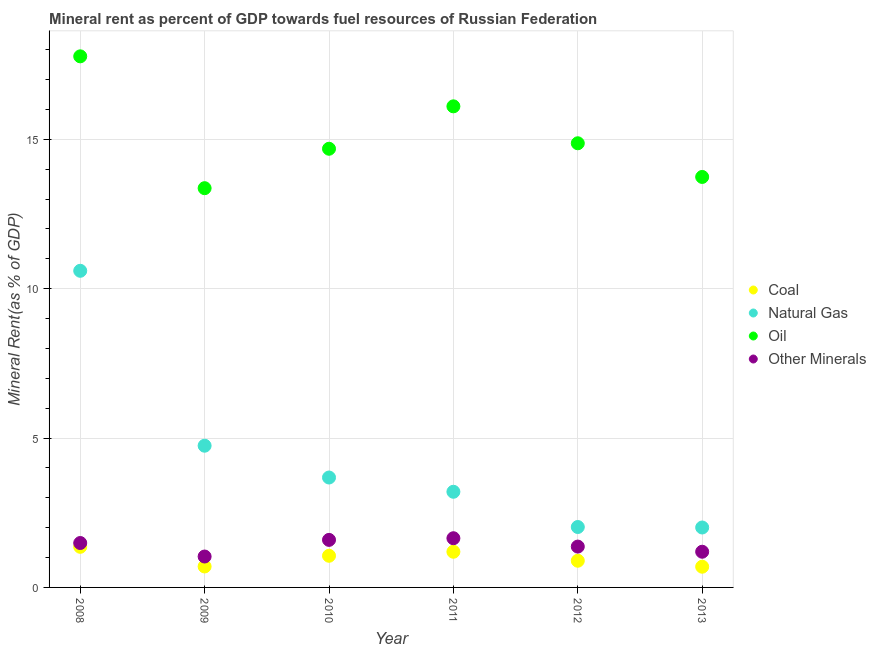How many different coloured dotlines are there?
Your answer should be very brief. 4. Is the number of dotlines equal to the number of legend labels?
Make the answer very short. Yes. What is the  rent of other minerals in 2009?
Offer a terse response. 1.03. Across all years, what is the maximum oil rent?
Give a very brief answer. 17.77. Across all years, what is the minimum oil rent?
Offer a very short reply. 13.36. What is the total natural gas rent in the graph?
Ensure brevity in your answer.  26.25. What is the difference between the natural gas rent in 2009 and that in 2012?
Offer a very short reply. 2.72. What is the difference between the oil rent in 2013 and the  rent of other minerals in 2012?
Your answer should be very brief. 12.37. What is the average coal rent per year?
Keep it short and to the point. 0.98. In the year 2008, what is the difference between the  rent of other minerals and oil rent?
Your answer should be compact. -16.29. What is the ratio of the coal rent in 2012 to that in 2013?
Provide a short and direct response. 1.29. Is the difference between the oil rent in 2009 and 2013 greater than the difference between the coal rent in 2009 and 2013?
Offer a very short reply. No. What is the difference between the highest and the second highest  rent of other minerals?
Offer a terse response. 0.06. What is the difference between the highest and the lowest coal rent?
Offer a terse response. 0.67. Is the sum of the coal rent in 2010 and 2013 greater than the maximum oil rent across all years?
Your response must be concise. No. Is it the case that in every year, the sum of the coal rent and natural gas rent is greater than the oil rent?
Your response must be concise. No. Does the  rent of other minerals monotonically increase over the years?
Your response must be concise. No. How many dotlines are there?
Your answer should be very brief. 4. How many years are there in the graph?
Make the answer very short. 6. What is the difference between two consecutive major ticks on the Y-axis?
Your answer should be very brief. 5. Are the values on the major ticks of Y-axis written in scientific E-notation?
Make the answer very short. No. Does the graph contain grids?
Keep it short and to the point. Yes. Where does the legend appear in the graph?
Provide a short and direct response. Center right. What is the title of the graph?
Provide a succinct answer. Mineral rent as percent of GDP towards fuel resources of Russian Federation. Does "Quality of logistic services" appear as one of the legend labels in the graph?
Offer a terse response. No. What is the label or title of the X-axis?
Provide a short and direct response. Year. What is the label or title of the Y-axis?
Offer a very short reply. Mineral Rent(as % of GDP). What is the Mineral Rent(as % of GDP) in Coal in 2008?
Your answer should be compact. 1.36. What is the Mineral Rent(as % of GDP) in Natural Gas in 2008?
Provide a succinct answer. 10.6. What is the Mineral Rent(as % of GDP) of Oil in 2008?
Make the answer very short. 17.77. What is the Mineral Rent(as % of GDP) of Other Minerals in 2008?
Provide a succinct answer. 1.49. What is the Mineral Rent(as % of GDP) in Coal in 2009?
Your answer should be very brief. 0.7. What is the Mineral Rent(as % of GDP) of Natural Gas in 2009?
Give a very brief answer. 4.74. What is the Mineral Rent(as % of GDP) in Oil in 2009?
Your response must be concise. 13.36. What is the Mineral Rent(as % of GDP) in Other Minerals in 2009?
Offer a very short reply. 1.03. What is the Mineral Rent(as % of GDP) in Coal in 2010?
Offer a very short reply. 1.06. What is the Mineral Rent(as % of GDP) of Natural Gas in 2010?
Give a very brief answer. 3.68. What is the Mineral Rent(as % of GDP) of Oil in 2010?
Provide a short and direct response. 14.68. What is the Mineral Rent(as % of GDP) in Other Minerals in 2010?
Your response must be concise. 1.59. What is the Mineral Rent(as % of GDP) in Coal in 2011?
Ensure brevity in your answer.  1.19. What is the Mineral Rent(as % of GDP) in Natural Gas in 2011?
Your response must be concise. 3.2. What is the Mineral Rent(as % of GDP) of Oil in 2011?
Offer a very short reply. 16.1. What is the Mineral Rent(as % of GDP) of Other Minerals in 2011?
Offer a terse response. 1.65. What is the Mineral Rent(as % of GDP) of Coal in 2012?
Your answer should be compact. 0.89. What is the Mineral Rent(as % of GDP) in Natural Gas in 2012?
Keep it short and to the point. 2.02. What is the Mineral Rent(as % of GDP) of Oil in 2012?
Make the answer very short. 14.87. What is the Mineral Rent(as % of GDP) of Other Minerals in 2012?
Offer a terse response. 1.37. What is the Mineral Rent(as % of GDP) in Coal in 2013?
Ensure brevity in your answer.  0.69. What is the Mineral Rent(as % of GDP) in Natural Gas in 2013?
Ensure brevity in your answer.  2.01. What is the Mineral Rent(as % of GDP) in Oil in 2013?
Provide a short and direct response. 13.74. What is the Mineral Rent(as % of GDP) in Other Minerals in 2013?
Give a very brief answer. 1.19. Across all years, what is the maximum Mineral Rent(as % of GDP) in Coal?
Make the answer very short. 1.36. Across all years, what is the maximum Mineral Rent(as % of GDP) in Natural Gas?
Your answer should be very brief. 10.6. Across all years, what is the maximum Mineral Rent(as % of GDP) in Oil?
Offer a very short reply. 17.77. Across all years, what is the maximum Mineral Rent(as % of GDP) of Other Minerals?
Make the answer very short. 1.65. Across all years, what is the minimum Mineral Rent(as % of GDP) in Coal?
Give a very brief answer. 0.69. Across all years, what is the minimum Mineral Rent(as % of GDP) of Natural Gas?
Your response must be concise. 2.01. Across all years, what is the minimum Mineral Rent(as % of GDP) in Oil?
Give a very brief answer. 13.36. Across all years, what is the minimum Mineral Rent(as % of GDP) of Other Minerals?
Provide a succinct answer. 1.03. What is the total Mineral Rent(as % of GDP) of Coal in the graph?
Provide a succinct answer. 5.9. What is the total Mineral Rent(as % of GDP) of Natural Gas in the graph?
Make the answer very short. 26.25. What is the total Mineral Rent(as % of GDP) in Oil in the graph?
Give a very brief answer. 90.52. What is the total Mineral Rent(as % of GDP) of Other Minerals in the graph?
Your answer should be very brief. 8.32. What is the difference between the Mineral Rent(as % of GDP) in Coal in 2008 and that in 2009?
Give a very brief answer. 0.66. What is the difference between the Mineral Rent(as % of GDP) of Natural Gas in 2008 and that in 2009?
Your answer should be compact. 5.85. What is the difference between the Mineral Rent(as % of GDP) of Oil in 2008 and that in 2009?
Give a very brief answer. 4.41. What is the difference between the Mineral Rent(as % of GDP) of Other Minerals in 2008 and that in 2009?
Make the answer very short. 0.45. What is the difference between the Mineral Rent(as % of GDP) of Coal in 2008 and that in 2010?
Offer a very short reply. 0.3. What is the difference between the Mineral Rent(as % of GDP) of Natural Gas in 2008 and that in 2010?
Offer a very short reply. 6.92. What is the difference between the Mineral Rent(as % of GDP) in Oil in 2008 and that in 2010?
Make the answer very short. 3.09. What is the difference between the Mineral Rent(as % of GDP) in Other Minerals in 2008 and that in 2010?
Your answer should be compact. -0.1. What is the difference between the Mineral Rent(as % of GDP) in Coal in 2008 and that in 2011?
Offer a very short reply. 0.17. What is the difference between the Mineral Rent(as % of GDP) in Natural Gas in 2008 and that in 2011?
Your response must be concise. 7.4. What is the difference between the Mineral Rent(as % of GDP) of Oil in 2008 and that in 2011?
Give a very brief answer. 1.67. What is the difference between the Mineral Rent(as % of GDP) in Other Minerals in 2008 and that in 2011?
Give a very brief answer. -0.16. What is the difference between the Mineral Rent(as % of GDP) of Coal in 2008 and that in 2012?
Give a very brief answer. 0.47. What is the difference between the Mineral Rent(as % of GDP) in Natural Gas in 2008 and that in 2012?
Offer a terse response. 8.57. What is the difference between the Mineral Rent(as % of GDP) of Oil in 2008 and that in 2012?
Offer a very short reply. 2.91. What is the difference between the Mineral Rent(as % of GDP) in Other Minerals in 2008 and that in 2012?
Your response must be concise. 0.12. What is the difference between the Mineral Rent(as % of GDP) of Coal in 2008 and that in 2013?
Provide a succinct answer. 0.67. What is the difference between the Mineral Rent(as % of GDP) of Natural Gas in 2008 and that in 2013?
Offer a terse response. 8.59. What is the difference between the Mineral Rent(as % of GDP) of Oil in 2008 and that in 2013?
Provide a succinct answer. 4.04. What is the difference between the Mineral Rent(as % of GDP) in Other Minerals in 2008 and that in 2013?
Offer a terse response. 0.29. What is the difference between the Mineral Rent(as % of GDP) in Coal in 2009 and that in 2010?
Provide a short and direct response. -0.36. What is the difference between the Mineral Rent(as % of GDP) in Natural Gas in 2009 and that in 2010?
Make the answer very short. 1.06. What is the difference between the Mineral Rent(as % of GDP) in Oil in 2009 and that in 2010?
Keep it short and to the point. -1.32. What is the difference between the Mineral Rent(as % of GDP) of Other Minerals in 2009 and that in 2010?
Provide a succinct answer. -0.56. What is the difference between the Mineral Rent(as % of GDP) of Coal in 2009 and that in 2011?
Make the answer very short. -0.49. What is the difference between the Mineral Rent(as % of GDP) in Natural Gas in 2009 and that in 2011?
Keep it short and to the point. 1.54. What is the difference between the Mineral Rent(as % of GDP) in Oil in 2009 and that in 2011?
Your answer should be very brief. -2.74. What is the difference between the Mineral Rent(as % of GDP) of Other Minerals in 2009 and that in 2011?
Your response must be concise. -0.61. What is the difference between the Mineral Rent(as % of GDP) of Coal in 2009 and that in 2012?
Offer a terse response. -0.19. What is the difference between the Mineral Rent(as % of GDP) of Natural Gas in 2009 and that in 2012?
Make the answer very short. 2.72. What is the difference between the Mineral Rent(as % of GDP) in Oil in 2009 and that in 2012?
Offer a very short reply. -1.5. What is the difference between the Mineral Rent(as % of GDP) of Other Minerals in 2009 and that in 2012?
Provide a succinct answer. -0.33. What is the difference between the Mineral Rent(as % of GDP) in Coal in 2009 and that in 2013?
Give a very brief answer. 0.01. What is the difference between the Mineral Rent(as % of GDP) of Natural Gas in 2009 and that in 2013?
Give a very brief answer. 2.74. What is the difference between the Mineral Rent(as % of GDP) of Oil in 2009 and that in 2013?
Offer a terse response. -0.38. What is the difference between the Mineral Rent(as % of GDP) of Other Minerals in 2009 and that in 2013?
Ensure brevity in your answer.  -0.16. What is the difference between the Mineral Rent(as % of GDP) of Coal in 2010 and that in 2011?
Your answer should be very brief. -0.13. What is the difference between the Mineral Rent(as % of GDP) of Natural Gas in 2010 and that in 2011?
Your answer should be very brief. 0.48. What is the difference between the Mineral Rent(as % of GDP) of Oil in 2010 and that in 2011?
Make the answer very short. -1.42. What is the difference between the Mineral Rent(as % of GDP) of Other Minerals in 2010 and that in 2011?
Give a very brief answer. -0.06. What is the difference between the Mineral Rent(as % of GDP) in Coal in 2010 and that in 2012?
Your answer should be very brief. 0.17. What is the difference between the Mineral Rent(as % of GDP) in Natural Gas in 2010 and that in 2012?
Your answer should be compact. 1.66. What is the difference between the Mineral Rent(as % of GDP) of Oil in 2010 and that in 2012?
Give a very brief answer. -0.18. What is the difference between the Mineral Rent(as % of GDP) in Other Minerals in 2010 and that in 2012?
Keep it short and to the point. 0.22. What is the difference between the Mineral Rent(as % of GDP) of Coal in 2010 and that in 2013?
Offer a terse response. 0.37. What is the difference between the Mineral Rent(as % of GDP) of Natural Gas in 2010 and that in 2013?
Provide a short and direct response. 1.67. What is the difference between the Mineral Rent(as % of GDP) of Oil in 2010 and that in 2013?
Your response must be concise. 0.94. What is the difference between the Mineral Rent(as % of GDP) of Other Minerals in 2010 and that in 2013?
Offer a very short reply. 0.4. What is the difference between the Mineral Rent(as % of GDP) in Coal in 2011 and that in 2012?
Ensure brevity in your answer.  0.3. What is the difference between the Mineral Rent(as % of GDP) of Natural Gas in 2011 and that in 2012?
Keep it short and to the point. 1.18. What is the difference between the Mineral Rent(as % of GDP) in Oil in 2011 and that in 2012?
Provide a short and direct response. 1.24. What is the difference between the Mineral Rent(as % of GDP) of Other Minerals in 2011 and that in 2012?
Provide a succinct answer. 0.28. What is the difference between the Mineral Rent(as % of GDP) of Coal in 2011 and that in 2013?
Provide a short and direct response. 0.5. What is the difference between the Mineral Rent(as % of GDP) in Natural Gas in 2011 and that in 2013?
Provide a succinct answer. 1.2. What is the difference between the Mineral Rent(as % of GDP) of Oil in 2011 and that in 2013?
Offer a very short reply. 2.36. What is the difference between the Mineral Rent(as % of GDP) in Other Minerals in 2011 and that in 2013?
Your answer should be very brief. 0.45. What is the difference between the Mineral Rent(as % of GDP) of Coal in 2012 and that in 2013?
Keep it short and to the point. 0.2. What is the difference between the Mineral Rent(as % of GDP) in Natural Gas in 2012 and that in 2013?
Offer a terse response. 0.02. What is the difference between the Mineral Rent(as % of GDP) in Oil in 2012 and that in 2013?
Keep it short and to the point. 1.13. What is the difference between the Mineral Rent(as % of GDP) in Other Minerals in 2012 and that in 2013?
Make the answer very short. 0.17. What is the difference between the Mineral Rent(as % of GDP) in Coal in 2008 and the Mineral Rent(as % of GDP) in Natural Gas in 2009?
Your response must be concise. -3.38. What is the difference between the Mineral Rent(as % of GDP) of Coal in 2008 and the Mineral Rent(as % of GDP) of Oil in 2009?
Ensure brevity in your answer.  -12. What is the difference between the Mineral Rent(as % of GDP) in Coal in 2008 and the Mineral Rent(as % of GDP) in Other Minerals in 2009?
Offer a terse response. 0.32. What is the difference between the Mineral Rent(as % of GDP) of Natural Gas in 2008 and the Mineral Rent(as % of GDP) of Oil in 2009?
Your answer should be compact. -2.77. What is the difference between the Mineral Rent(as % of GDP) in Natural Gas in 2008 and the Mineral Rent(as % of GDP) in Other Minerals in 2009?
Your answer should be very brief. 9.56. What is the difference between the Mineral Rent(as % of GDP) in Oil in 2008 and the Mineral Rent(as % of GDP) in Other Minerals in 2009?
Offer a very short reply. 16.74. What is the difference between the Mineral Rent(as % of GDP) of Coal in 2008 and the Mineral Rent(as % of GDP) of Natural Gas in 2010?
Provide a succinct answer. -2.32. What is the difference between the Mineral Rent(as % of GDP) of Coal in 2008 and the Mineral Rent(as % of GDP) of Oil in 2010?
Provide a short and direct response. -13.32. What is the difference between the Mineral Rent(as % of GDP) of Coal in 2008 and the Mineral Rent(as % of GDP) of Other Minerals in 2010?
Make the answer very short. -0.23. What is the difference between the Mineral Rent(as % of GDP) of Natural Gas in 2008 and the Mineral Rent(as % of GDP) of Oil in 2010?
Your answer should be compact. -4.08. What is the difference between the Mineral Rent(as % of GDP) in Natural Gas in 2008 and the Mineral Rent(as % of GDP) in Other Minerals in 2010?
Provide a succinct answer. 9.01. What is the difference between the Mineral Rent(as % of GDP) in Oil in 2008 and the Mineral Rent(as % of GDP) in Other Minerals in 2010?
Your answer should be compact. 16.18. What is the difference between the Mineral Rent(as % of GDP) of Coal in 2008 and the Mineral Rent(as % of GDP) of Natural Gas in 2011?
Your response must be concise. -1.84. What is the difference between the Mineral Rent(as % of GDP) in Coal in 2008 and the Mineral Rent(as % of GDP) in Oil in 2011?
Offer a very short reply. -14.74. What is the difference between the Mineral Rent(as % of GDP) of Coal in 2008 and the Mineral Rent(as % of GDP) of Other Minerals in 2011?
Give a very brief answer. -0.29. What is the difference between the Mineral Rent(as % of GDP) of Natural Gas in 2008 and the Mineral Rent(as % of GDP) of Oil in 2011?
Provide a succinct answer. -5.5. What is the difference between the Mineral Rent(as % of GDP) of Natural Gas in 2008 and the Mineral Rent(as % of GDP) of Other Minerals in 2011?
Provide a succinct answer. 8.95. What is the difference between the Mineral Rent(as % of GDP) in Oil in 2008 and the Mineral Rent(as % of GDP) in Other Minerals in 2011?
Offer a terse response. 16.13. What is the difference between the Mineral Rent(as % of GDP) in Coal in 2008 and the Mineral Rent(as % of GDP) in Natural Gas in 2012?
Keep it short and to the point. -0.66. What is the difference between the Mineral Rent(as % of GDP) in Coal in 2008 and the Mineral Rent(as % of GDP) in Oil in 2012?
Your response must be concise. -13.51. What is the difference between the Mineral Rent(as % of GDP) of Coal in 2008 and the Mineral Rent(as % of GDP) of Other Minerals in 2012?
Your answer should be very brief. -0.01. What is the difference between the Mineral Rent(as % of GDP) in Natural Gas in 2008 and the Mineral Rent(as % of GDP) in Oil in 2012?
Your answer should be very brief. -4.27. What is the difference between the Mineral Rent(as % of GDP) of Natural Gas in 2008 and the Mineral Rent(as % of GDP) of Other Minerals in 2012?
Your response must be concise. 9.23. What is the difference between the Mineral Rent(as % of GDP) in Oil in 2008 and the Mineral Rent(as % of GDP) in Other Minerals in 2012?
Make the answer very short. 16.41. What is the difference between the Mineral Rent(as % of GDP) in Coal in 2008 and the Mineral Rent(as % of GDP) in Natural Gas in 2013?
Offer a terse response. -0.65. What is the difference between the Mineral Rent(as % of GDP) in Coal in 2008 and the Mineral Rent(as % of GDP) in Oil in 2013?
Keep it short and to the point. -12.38. What is the difference between the Mineral Rent(as % of GDP) of Coal in 2008 and the Mineral Rent(as % of GDP) of Other Minerals in 2013?
Your response must be concise. 0.16. What is the difference between the Mineral Rent(as % of GDP) of Natural Gas in 2008 and the Mineral Rent(as % of GDP) of Oil in 2013?
Make the answer very short. -3.14. What is the difference between the Mineral Rent(as % of GDP) of Natural Gas in 2008 and the Mineral Rent(as % of GDP) of Other Minerals in 2013?
Offer a terse response. 9.4. What is the difference between the Mineral Rent(as % of GDP) of Oil in 2008 and the Mineral Rent(as % of GDP) of Other Minerals in 2013?
Offer a terse response. 16.58. What is the difference between the Mineral Rent(as % of GDP) in Coal in 2009 and the Mineral Rent(as % of GDP) in Natural Gas in 2010?
Ensure brevity in your answer.  -2.98. What is the difference between the Mineral Rent(as % of GDP) in Coal in 2009 and the Mineral Rent(as % of GDP) in Oil in 2010?
Your answer should be compact. -13.98. What is the difference between the Mineral Rent(as % of GDP) of Coal in 2009 and the Mineral Rent(as % of GDP) of Other Minerals in 2010?
Give a very brief answer. -0.89. What is the difference between the Mineral Rent(as % of GDP) of Natural Gas in 2009 and the Mineral Rent(as % of GDP) of Oil in 2010?
Provide a succinct answer. -9.94. What is the difference between the Mineral Rent(as % of GDP) of Natural Gas in 2009 and the Mineral Rent(as % of GDP) of Other Minerals in 2010?
Provide a succinct answer. 3.15. What is the difference between the Mineral Rent(as % of GDP) in Oil in 2009 and the Mineral Rent(as % of GDP) in Other Minerals in 2010?
Provide a short and direct response. 11.77. What is the difference between the Mineral Rent(as % of GDP) in Coal in 2009 and the Mineral Rent(as % of GDP) in Natural Gas in 2011?
Your answer should be very brief. -2.5. What is the difference between the Mineral Rent(as % of GDP) of Coal in 2009 and the Mineral Rent(as % of GDP) of Oil in 2011?
Your answer should be very brief. -15.4. What is the difference between the Mineral Rent(as % of GDP) in Coal in 2009 and the Mineral Rent(as % of GDP) in Other Minerals in 2011?
Offer a terse response. -0.95. What is the difference between the Mineral Rent(as % of GDP) in Natural Gas in 2009 and the Mineral Rent(as % of GDP) in Oil in 2011?
Give a very brief answer. -11.36. What is the difference between the Mineral Rent(as % of GDP) of Natural Gas in 2009 and the Mineral Rent(as % of GDP) of Other Minerals in 2011?
Your response must be concise. 3.1. What is the difference between the Mineral Rent(as % of GDP) in Oil in 2009 and the Mineral Rent(as % of GDP) in Other Minerals in 2011?
Keep it short and to the point. 11.72. What is the difference between the Mineral Rent(as % of GDP) in Coal in 2009 and the Mineral Rent(as % of GDP) in Natural Gas in 2012?
Provide a succinct answer. -1.32. What is the difference between the Mineral Rent(as % of GDP) in Coal in 2009 and the Mineral Rent(as % of GDP) in Oil in 2012?
Keep it short and to the point. -14.16. What is the difference between the Mineral Rent(as % of GDP) of Coal in 2009 and the Mineral Rent(as % of GDP) of Other Minerals in 2012?
Keep it short and to the point. -0.67. What is the difference between the Mineral Rent(as % of GDP) of Natural Gas in 2009 and the Mineral Rent(as % of GDP) of Oil in 2012?
Keep it short and to the point. -10.12. What is the difference between the Mineral Rent(as % of GDP) in Natural Gas in 2009 and the Mineral Rent(as % of GDP) in Other Minerals in 2012?
Offer a very short reply. 3.38. What is the difference between the Mineral Rent(as % of GDP) of Oil in 2009 and the Mineral Rent(as % of GDP) of Other Minerals in 2012?
Make the answer very short. 12. What is the difference between the Mineral Rent(as % of GDP) in Coal in 2009 and the Mineral Rent(as % of GDP) in Natural Gas in 2013?
Your response must be concise. -1.3. What is the difference between the Mineral Rent(as % of GDP) in Coal in 2009 and the Mineral Rent(as % of GDP) in Oil in 2013?
Provide a succinct answer. -13.04. What is the difference between the Mineral Rent(as % of GDP) of Coal in 2009 and the Mineral Rent(as % of GDP) of Other Minerals in 2013?
Give a very brief answer. -0.49. What is the difference between the Mineral Rent(as % of GDP) in Natural Gas in 2009 and the Mineral Rent(as % of GDP) in Oil in 2013?
Give a very brief answer. -9. What is the difference between the Mineral Rent(as % of GDP) in Natural Gas in 2009 and the Mineral Rent(as % of GDP) in Other Minerals in 2013?
Your response must be concise. 3.55. What is the difference between the Mineral Rent(as % of GDP) in Oil in 2009 and the Mineral Rent(as % of GDP) in Other Minerals in 2013?
Offer a terse response. 12.17. What is the difference between the Mineral Rent(as % of GDP) in Coal in 2010 and the Mineral Rent(as % of GDP) in Natural Gas in 2011?
Keep it short and to the point. -2.14. What is the difference between the Mineral Rent(as % of GDP) in Coal in 2010 and the Mineral Rent(as % of GDP) in Oil in 2011?
Offer a terse response. -15.04. What is the difference between the Mineral Rent(as % of GDP) of Coal in 2010 and the Mineral Rent(as % of GDP) of Other Minerals in 2011?
Keep it short and to the point. -0.59. What is the difference between the Mineral Rent(as % of GDP) of Natural Gas in 2010 and the Mineral Rent(as % of GDP) of Oil in 2011?
Your answer should be compact. -12.42. What is the difference between the Mineral Rent(as % of GDP) of Natural Gas in 2010 and the Mineral Rent(as % of GDP) of Other Minerals in 2011?
Make the answer very short. 2.03. What is the difference between the Mineral Rent(as % of GDP) in Oil in 2010 and the Mineral Rent(as % of GDP) in Other Minerals in 2011?
Your answer should be compact. 13.04. What is the difference between the Mineral Rent(as % of GDP) in Coal in 2010 and the Mineral Rent(as % of GDP) in Natural Gas in 2012?
Keep it short and to the point. -0.96. What is the difference between the Mineral Rent(as % of GDP) of Coal in 2010 and the Mineral Rent(as % of GDP) of Oil in 2012?
Give a very brief answer. -13.81. What is the difference between the Mineral Rent(as % of GDP) of Coal in 2010 and the Mineral Rent(as % of GDP) of Other Minerals in 2012?
Provide a succinct answer. -0.31. What is the difference between the Mineral Rent(as % of GDP) of Natural Gas in 2010 and the Mineral Rent(as % of GDP) of Oil in 2012?
Your answer should be compact. -11.19. What is the difference between the Mineral Rent(as % of GDP) of Natural Gas in 2010 and the Mineral Rent(as % of GDP) of Other Minerals in 2012?
Keep it short and to the point. 2.31. What is the difference between the Mineral Rent(as % of GDP) in Oil in 2010 and the Mineral Rent(as % of GDP) in Other Minerals in 2012?
Keep it short and to the point. 13.31. What is the difference between the Mineral Rent(as % of GDP) in Coal in 2010 and the Mineral Rent(as % of GDP) in Natural Gas in 2013?
Offer a very short reply. -0.95. What is the difference between the Mineral Rent(as % of GDP) of Coal in 2010 and the Mineral Rent(as % of GDP) of Oil in 2013?
Give a very brief answer. -12.68. What is the difference between the Mineral Rent(as % of GDP) in Coal in 2010 and the Mineral Rent(as % of GDP) in Other Minerals in 2013?
Your response must be concise. -0.14. What is the difference between the Mineral Rent(as % of GDP) in Natural Gas in 2010 and the Mineral Rent(as % of GDP) in Oil in 2013?
Your answer should be compact. -10.06. What is the difference between the Mineral Rent(as % of GDP) in Natural Gas in 2010 and the Mineral Rent(as % of GDP) in Other Minerals in 2013?
Give a very brief answer. 2.48. What is the difference between the Mineral Rent(as % of GDP) of Oil in 2010 and the Mineral Rent(as % of GDP) of Other Minerals in 2013?
Offer a very short reply. 13.49. What is the difference between the Mineral Rent(as % of GDP) in Coal in 2011 and the Mineral Rent(as % of GDP) in Natural Gas in 2012?
Your response must be concise. -0.83. What is the difference between the Mineral Rent(as % of GDP) in Coal in 2011 and the Mineral Rent(as % of GDP) in Oil in 2012?
Your answer should be very brief. -13.67. What is the difference between the Mineral Rent(as % of GDP) of Coal in 2011 and the Mineral Rent(as % of GDP) of Other Minerals in 2012?
Make the answer very short. -0.17. What is the difference between the Mineral Rent(as % of GDP) in Natural Gas in 2011 and the Mineral Rent(as % of GDP) in Oil in 2012?
Offer a terse response. -11.66. What is the difference between the Mineral Rent(as % of GDP) of Natural Gas in 2011 and the Mineral Rent(as % of GDP) of Other Minerals in 2012?
Offer a very short reply. 1.83. What is the difference between the Mineral Rent(as % of GDP) of Oil in 2011 and the Mineral Rent(as % of GDP) of Other Minerals in 2012?
Provide a short and direct response. 14.73. What is the difference between the Mineral Rent(as % of GDP) of Coal in 2011 and the Mineral Rent(as % of GDP) of Natural Gas in 2013?
Give a very brief answer. -0.81. What is the difference between the Mineral Rent(as % of GDP) of Coal in 2011 and the Mineral Rent(as % of GDP) of Oil in 2013?
Give a very brief answer. -12.54. What is the difference between the Mineral Rent(as % of GDP) in Coal in 2011 and the Mineral Rent(as % of GDP) in Other Minerals in 2013?
Make the answer very short. -0. What is the difference between the Mineral Rent(as % of GDP) of Natural Gas in 2011 and the Mineral Rent(as % of GDP) of Oil in 2013?
Make the answer very short. -10.54. What is the difference between the Mineral Rent(as % of GDP) of Natural Gas in 2011 and the Mineral Rent(as % of GDP) of Other Minerals in 2013?
Make the answer very short. 2.01. What is the difference between the Mineral Rent(as % of GDP) in Oil in 2011 and the Mineral Rent(as % of GDP) in Other Minerals in 2013?
Your response must be concise. 14.91. What is the difference between the Mineral Rent(as % of GDP) of Coal in 2012 and the Mineral Rent(as % of GDP) of Natural Gas in 2013?
Ensure brevity in your answer.  -1.11. What is the difference between the Mineral Rent(as % of GDP) in Coal in 2012 and the Mineral Rent(as % of GDP) in Oil in 2013?
Offer a very short reply. -12.85. What is the difference between the Mineral Rent(as % of GDP) of Coal in 2012 and the Mineral Rent(as % of GDP) of Other Minerals in 2013?
Your response must be concise. -0.3. What is the difference between the Mineral Rent(as % of GDP) in Natural Gas in 2012 and the Mineral Rent(as % of GDP) in Oil in 2013?
Offer a very short reply. -11.72. What is the difference between the Mineral Rent(as % of GDP) of Natural Gas in 2012 and the Mineral Rent(as % of GDP) of Other Minerals in 2013?
Your response must be concise. 0.83. What is the difference between the Mineral Rent(as % of GDP) in Oil in 2012 and the Mineral Rent(as % of GDP) in Other Minerals in 2013?
Provide a short and direct response. 13.67. What is the average Mineral Rent(as % of GDP) of Coal per year?
Your answer should be compact. 0.98. What is the average Mineral Rent(as % of GDP) of Natural Gas per year?
Your answer should be compact. 4.37. What is the average Mineral Rent(as % of GDP) of Oil per year?
Your answer should be compact. 15.09. What is the average Mineral Rent(as % of GDP) in Other Minerals per year?
Make the answer very short. 1.39. In the year 2008, what is the difference between the Mineral Rent(as % of GDP) of Coal and Mineral Rent(as % of GDP) of Natural Gas?
Offer a terse response. -9.24. In the year 2008, what is the difference between the Mineral Rent(as % of GDP) in Coal and Mineral Rent(as % of GDP) in Oil?
Your answer should be very brief. -16.42. In the year 2008, what is the difference between the Mineral Rent(as % of GDP) of Coal and Mineral Rent(as % of GDP) of Other Minerals?
Make the answer very short. -0.13. In the year 2008, what is the difference between the Mineral Rent(as % of GDP) in Natural Gas and Mineral Rent(as % of GDP) in Oil?
Make the answer very short. -7.18. In the year 2008, what is the difference between the Mineral Rent(as % of GDP) of Natural Gas and Mineral Rent(as % of GDP) of Other Minerals?
Your answer should be very brief. 9.11. In the year 2008, what is the difference between the Mineral Rent(as % of GDP) of Oil and Mineral Rent(as % of GDP) of Other Minerals?
Make the answer very short. 16.29. In the year 2009, what is the difference between the Mineral Rent(as % of GDP) of Coal and Mineral Rent(as % of GDP) of Natural Gas?
Your response must be concise. -4.04. In the year 2009, what is the difference between the Mineral Rent(as % of GDP) in Coal and Mineral Rent(as % of GDP) in Oil?
Your answer should be compact. -12.66. In the year 2009, what is the difference between the Mineral Rent(as % of GDP) of Coal and Mineral Rent(as % of GDP) of Other Minerals?
Offer a very short reply. -0.33. In the year 2009, what is the difference between the Mineral Rent(as % of GDP) in Natural Gas and Mineral Rent(as % of GDP) in Oil?
Make the answer very short. -8.62. In the year 2009, what is the difference between the Mineral Rent(as % of GDP) in Natural Gas and Mineral Rent(as % of GDP) in Other Minerals?
Give a very brief answer. 3.71. In the year 2009, what is the difference between the Mineral Rent(as % of GDP) in Oil and Mineral Rent(as % of GDP) in Other Minerals?
Offer a terse response. 12.33. In the year 2010, what is the difference between the Mineral Rent(as % of GDP) of Coal and Mineral Rent(as % of GDP) of Natural Gas?
Provide a short and direct response. -2.62. In the year 2010, what is the difference between the Mineral Rent(as % of GDP) in Coal and Mineral Rent(as % of GDP) in Oil?
Your answer should be very brief. -13.62. In the year 2010, what is the difference between the Mineral Rent(as % of GDP) in Coal and Mineral Rent(as % of GDP) in Other Minerals?
Offer a terse response. -0.53. In the year 2010, what is the difference between the Mineral Rent(as % of GDP) of Natural Gas and Mineral Rent(as % of GDP) of Oil?
Give a very brief answer. -11. In the year 2010, what is the difference between the Mineral Rent(as % of GDP) in Natural Gas and Mineral Rent(as % of GDP) in Other Minerals?
Make the answer very short. 2.09. In the year 2010, what is the difference between the Mineral Rent(as % of GDP) in Oil and Mineral Rent(as % of GDP) in Other Minerals?
Make the answer very short. 13.09. In the year 2011, what is the difference between the Mineral Rent(as % of GDP) of Coal and Mineral Rent(as % of GDP) of Natural Gas?
Provide a short and direct response. -2.01. In the year 2011, what is the difference between the Mineral Rent(as % of GDP) in Coal and Mineral Rent(as % of GDP) in Oil?
Your answer should be very brief. -14.91. In the year 2011, what is the difference between the Mineral Rent(as % of GDP) of Coal and Mineral Rent(as % of GDP) of Other Minerals?
Give a very brief answer. -0.45. In the year 2011, what is the difference between the Mineral Rent(as % of GDP) in Natural Gas and Mineral Rent(as % of GDP) in Oil?
Offer a very short reply. -12.9. In the year 2011, what is the difference between the Mineral Rent(as % of GDP) of Natural Gas and Mineral Rent(as % of GDP) of Other Minerals?
Ensure brevity in your answer.  1.56. In the year 2011, what is the difference between the Mineral Rent(as % of GDP) in Oil and Mineral Rent(as % of GDP) in Other Minerals?
Give a very brief answer. 14.45. In the year 2012, what is the difference between the Mineral Rent(as % of GDP) in Coal and Mineral Rent(as % of GDP) in Natural Gas?
Your answer should be very brief. -1.13. In the year 2012, what is the difference between the Mineral Rent(as % of GDP) in Coal and Mineral Rent(as % of GDP) in Oil?
Give a very brief answer. -13.97. In the year 2012, what is the difference between the Mineral Rent(as % of GDP) of Coal and Mineral Rent(as % of GDP) of Other Minerals?
Your answer should be very brief. -0.47. In the year 2012, what is the difference between the Mineral Rent(as % of GDP) of Natural Gas and Mineral Rent(as % of GDP) of Oil?
Give a very brief answer. -12.84. In the year 2012, what is the difference between the Mineral Rent(as % of GDP) of Natural Gas and Mineral Rent(as % of GDP) of Other Minerals?
Provide a succinct answer. 0.66. In the year 2012, what is the difference between the Mineral Rent(as % of GDP) in Oil and Mineral Rent(as % of GDP) in Other Minerals?
Provide a short and direct response. 13.5. In the year 2013, what is the difference between the Mineral Rent(as % of GDP) in Coal and Mineral Rent(as % of GDP) in Natural Gas?
Offer a terse response. -1.31. In the year 2013, what is the difference between the Mineral Rent(as % of GDP) in Coal and Mineral Rent(as % of GDP) in Oil?
Offer a terse response. -13.04. In the year 2013, what is the difference between the Mineral Rent(as % of GDP) of Coal and Mineral Rent(as % of GDP) of Other Minerals?
Your answer should be very brief. -0.5. In the year 2013, what is the difference between the Mineral Rent(as % of GDP) of Natural Gas and Mineral Rent(as % of GDP) of Oil?
Give a very brief answer. -11.73. In the year 2013, what is the difference between the Mineral Rent(as % of GDP) in Natural Gas and Mineral Rent(as % of GDP) in Other Minerals?
Make the answer very short. 0.81. In the year 2013, what is the difference between the Mineral Rent(as % of GDP) of Oil and Mineral Rent(as % of GDP) of Other Minerals?
Your answer should be compact. 12.54. What is the ratio of the Mineral Rent(as % of GDP) of Coal in 2008 to that in 2009?
Ensure brevity in your answer.  1.94. What is the ratio of the Mineral Rent(as % of GDP) of Natural Gas in 2008 to that in 2009?
Your response must be concise. 2.23. What is the ratio of the Mineral Rent(as % of GDP) of Oil in 2008 to that in 2009?
Your answer should be compact. 1.33. What is the ratio of the Mineral Rent(as % of GDP) in Other Minerals in 2008 to that in 2009?
Your answer should be compact. 1.44. What is the ratio of the Mineral Rent(as % of GDP) of Coal in 2008 to that in 2010?
Offer a terse response. 1.28. What is the ratio of the Mineral Rent(as % of GDP) in Natural Gas in 2008 to that in 2010?
Offer a terse response. 2.88. What is the ratio of the Mineral Rent(as % of GDP) of Oil in 2008 to that in 2010?
Your answer should be compact. 1.21. What is the ratio of the Mineral Rent(as % of GDP) of Other Minerals in 2008 to that in 2010?
Your response must be concise. 0.93. What is the ratio of the Mineral Rent(as % of GDP) of Coal in 2008 to that in 2011?
Your answer should be very brief. 1.14. What is the ratio of the Mineral Rent(as % of GDP) of Natural Gas in 2008 to that in 2011?
Your response must be concise. 3.31. What is the ratio of the Mineral Rent(as % of GDP) of Oil in 2008 to that in 2011?
Ensure brevity in your answer.  1.1. What is the ratio of the Mineral Rent(as % of GDP) in Other Minerals in 2008 to that in 2011?
Give a very brief answer. 0.9. What is the ratio of the Mineral Rent(as % of GDP) of Coal in 2008 to that in 2012?
Make the answer very short. 1.52. What is the ratio of the Mineral Rent(as % of GDP) of Natural Gas in 2008 to that in 2012?
Give a very brief answer. 5.24. What is the ratio of the Mineral Rent(as % of GDP) in Oil in 2008 to that in 2012?
Provide a short and direct response. 1.2. What is the ratio of the Mineral Rent(as % of GDP) in Other Minerals in 2008 to that in 2012?
Offer a very short reply. 1.09. What is the ratio of the Mineral Rent(as % of GDP) in Coal in 2008 to that in 2013?
Your answer should be very brief. 1.96. What is the ratio of the Mineral Rent(as % of GDP) of Natural Gas in 2008 to that in 2013?
Ensure brevity in your answer.  5.28. What is the ratio of the Mineral Rent(as % of GDP) in Oil in 2008 to that in 2013?
Make the answer very short. 1.29. What is the ratio of the Mineral Rent(as % of GDP) of Other Minerals in 2008 to that in 2013?
Your response must be concise. 1.24. What is the ratio of the Mineral Rent(as % of GDP) in Coal in 2009 to that in 2010?
Your answer should be very brief. 0.66. What is the ratio of the Mineral Rent(as % of GDP) in Natural Gas in 2009 to that in 2010?
Make the answer very short. 1.29. What is the ratio of the Mineral Rent(as % of GDP) of Oil in 2009 to that in 2010?
Your answer should be compact. 0.91. What is the ratio of the Mineral Rent(as % of GDP) in Other Minerals in 2009 to that in 2010?
Ensure brevity in your answer.  0.65. What is the ratio of the Mineral Rent(as % of GDP) of Coal in 2009 to that in 2011?
Offer a terse response. 0.59. What is the ratio of the Mineral Rent(as % of GDP) in Natural Gas in 2009 to that in 2011?
Your answer should be compact. 1.48. What is the ratio of the Mineral Rent(as % of GDP) in Oil in 2009 to that in 2011?
Ensure brevity in your answer.  0.83. What is the ratio of the Mineral Rent(as % of GDP) in Other Minerals in 2009 to that in 2011?
Your answer should be very brief. 0.63. What is the ratio of the Mineral Rent(as % of GDP) of Coal in 2009 to that in 2012?
Ensure brevity in your answer.  0.79. What is the ratio of the Mineral Rent(as % of GDP) in Natural Gas in 2009 to that in 2012?
Offer a very short reply. 2.35. What is the ratio of the Mineral Rent(as % of GDP) in Oil in 2009 to that in 2012?
Give a very brief answer. 0.9. What is the ratio of the Mineral Rent(as % of GDP) in Other Minerals in 2009 to that in 2012?
Your answer should be very brief. 0.76. What is the ratio of the Mineral Rent(as % of GDP) in Coal in 2009 to that in 2013?
Offer a very short reply. 1.01. What is the ratio of the Mineral Rent(as % of GDP) in Natural Gas in 2009 to that in 2013?
Give a very brief answer. 2.36. What is the ratio of the Mineral Rent(as % of GDP) of Oil in 2009 to that in 2013?
Provide a short and direct response. 0.97. What is the ratio of the Mineral Rent(as % of GDP) of Other Minerals in 2009 to that in 2013?
Offer a terse response. 0.87. What is the ratio of the Mineral Rent(as % of GDP) of Coal in 2010 to that in 2011?
Provide a short and direct response. 0.89. What is the ratio of the Mineral Rent(as % of GDP) in Natural Gas in 2010 to that in 2011?
Offer a terse response. 1.15. What is the ratio of the Mineral Rent(as % of GDP) of Oil in 2010 to that in 2011?
Your answer should be very brief. 0.91. What is the ratio of the Mineral Rent(as % of GDP) in Other Minerals in 2010 to that in 2011?
Your answer should be very brief. 0.97. What is the ratio of the Mineral Rent(as % of GDP) in Coal in 2010 to that in 2012?
Keep it short and to the point. 1.19. What is the ratio of the Mineral Rent(as % of GDP) in Natural Gas in 2010 to that in 2012?
Give a very brief answer. 1.82. What is the ratio of the Mineral Rent(as % of GDP) in Oil in 2010 to that in 2012?
Provide a short and direct response. 0.99. What is the ratio of the Mineral Rent(as % of GDP) in Other Minerals in 2010 to that in 2012?
Your response must be concise. 1.16. What is the ratio of the Mineral Rent(as % of GDP) of Coal in 2010 to that in 2013?
Your answer should be very brief. 1.53. What is the ratio of the Mineral Rent(as % of GDP) of Natural Gas in 2010 to that in 2013?
Your response must be concise. 1.83. What is the ratio of the Mineral Rent(as % of GDP) of Oil in 2010 to that in 2013?
Give a very brief answer. 1.07. What is the ratio of the Mineral Rent(as % of GDP) in Other Minerals in 2010 to that in 2013?
Offer a terse response. 1.33. What is the ratio of the Mineral Rent(as % of GDP) of Coal in 2011 to that in 2012?
Provide a succinct answer. 1.34. What is the ratio of the Mineral Rent(as % of GDP) of Natural Gas in 2011 to that in 2012?
Make the answer very short. 1.58. What is the ratio of the Mineral Rent(as % of GDP) of Oil in 2011 to that in 2012?
Provide a succinct answer. 1.08. What is the ratio of the Mineral Rent(as % of GDP) in Other Minerals in 2011 to that in 2012?
Ensure brevity in your answer.  1.2. What is the ratio of the Mineral Rent(as % of GDP) of Coal in 2011 to that in 2013?
Provide a succinct answer. 1.72. What is the ratio of the Mineral Rent(as % of GDP) of Natural Gas in 2011 to that in 2013?
Keep it short and to the point. 1.6. What is the ratio of the Mineral Rent(as % of GDP) in Oil in 2011 to that in 2013?
Ensure brevity in your answer.  1.17. What is the ratio of the Mineral Rent(as % of GDP) in Other Minerals in 2011 to that in 2013?
Keep it short and to the point. 1.38. What is the ratio of the Mineral Rent(as % of GDP) of Coal in 2012 to that in 2013?
Your answer should be very brief. 1.29. What is the ratio of the Mineral Rent(as % of GDP) of Natural Gas in 2012 to that in 2013?
Ensure brevity in your answer.  1.01. What is the ratio of the Mineral Rent(as % of GDP) of Oil in 2012 to that in 2013?
Make the answer very short. 1.08. What is the ratio of the Mineral Rent(as % of GDP) of Other Minerals in 2012 to that in 2013?
Give a very brief answer. 1.14. What is the difference between the highest and the second highest Mineral Rent(as % of GDP) in Coal?
Your response must be concise. 0.17. What is the difference between the highest and the second highest Mineral Rent(as % of GDP) of Natural Gas?
Offer a terse response. 5.85. What is the difference between the highest and the second highest Mineral Rent(as % of GDP) of Oil?
Provide a short and direct response. 1.67. What is the difference between the highest and the second highest Mineral Rent(as % of GDP) in Other Minerals?
Offer a terse response. 0.06. What is the difference between the highest and the lowest Mineral Rent(as % of GDP) of Coal?
Make the answer very short. 0.67. What is the difference between the highest and the lowest Mineral Rent(as % of GDP) in Natural Gas?
Your response must be concise. 8.59. What is the difference between the highest and the lowest Mineral Rent(as % of GDP) of Oil?
Keep it short and to the point. 4.41. What is the difference between the highest and the lowest Mineral Rent(as % of GDP) of Other Minerals?
Offer a terse response. 0.61. 